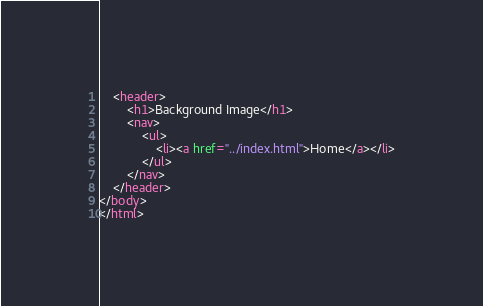<code> <loc_0><loc_0><loc_500><loc_500><_HTML_>    <header>
        <h1>Background Image</h1>
        <nav>
            <ul>
                <li><a href="../index.html">Home</a></li>
            </ul>
        </nav>
    </header>
</body>
</html></code> 